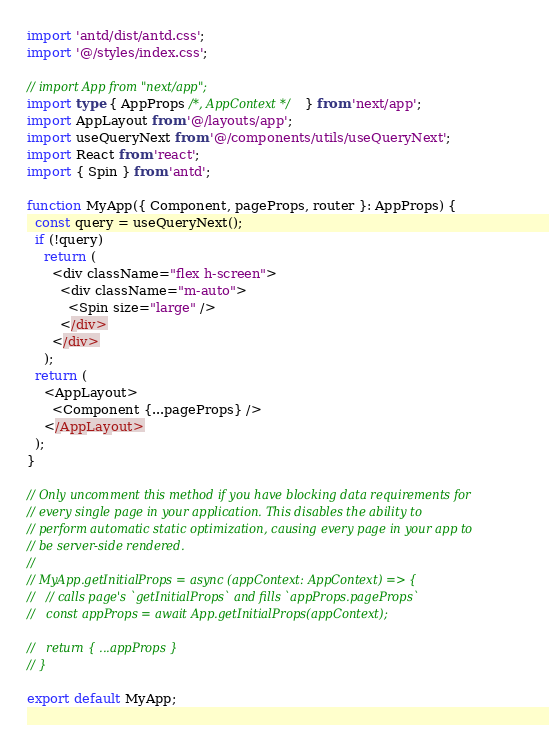<code> <loc_0><loc_0><loc_500><loc_500><_TypeScript_>import 'antd/dist/antd.css';
import '@/styles/index.css';

// import App from "next/app";
import type { AppProps /*, AppContext */ } from 'next/app';
import AppLayout from '@/layouts/app';
import useQueryNext from '@/components/utils/useQueryNext';
import React from 'react';
import { Spin } from 'antd';

function MyApp({ Component, pageProps, router }: AppProps) {
  const query = useQueryNext();
  if (!query)
    return (
      <div className="flex h-screen">
        <div className="m-auto">
          <Spin size="large" />
        </div>
      </div>
    );
  return (
    <AppLayout>
      <Component {...pageProps} />
    </AppLayout>
  );
}

// Only uncomment this method if you have blocking data requirements for
// every single page in your application. This disables the ability to
// perform automatic static optimization, causing every page in your app to
// be server-side rendered.
//
// MyApp.getInitialProps = async (appContext: AppContext) => {
//   // calls page's `getInitialProps` and fills `appProps.pageProps`
//   const appProps = await App.getInitialProps(appContext);

//   return { ...appProps }
// }

export default MyApp;
</code> 